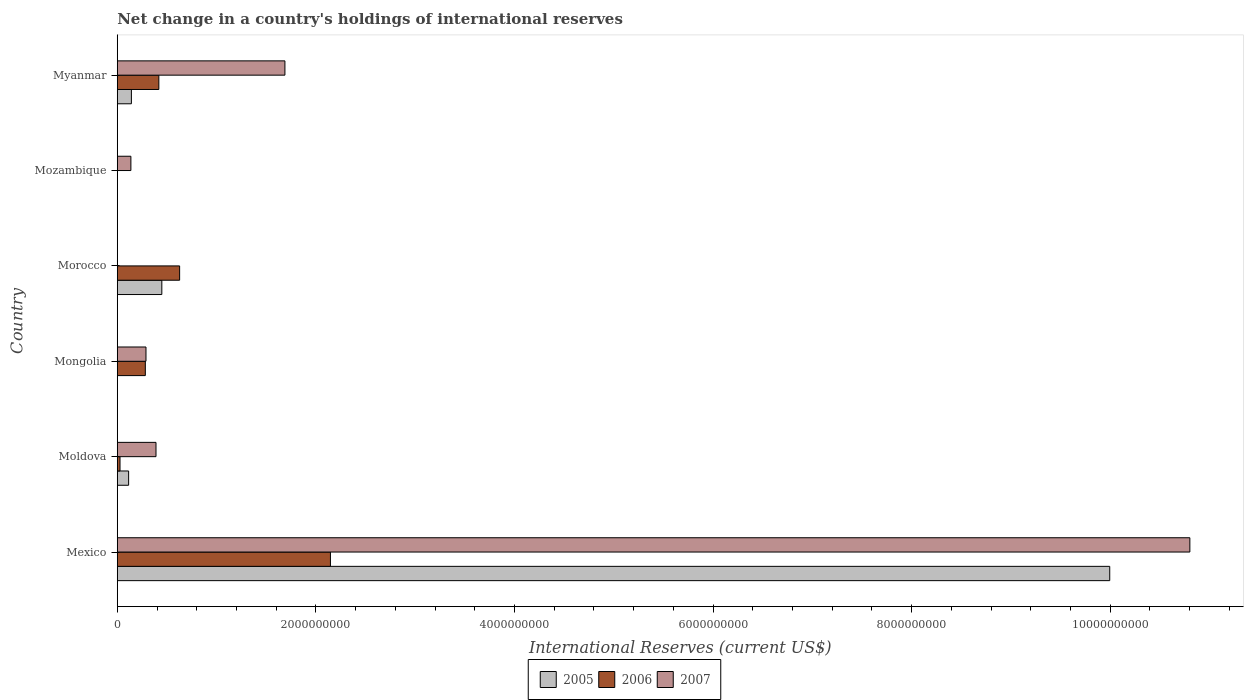How many different coloured bars are there?
Your answer should be compact. 3. How many bars are there on the 2nd tick from the bottom?
Provide a succinct answer. 3. What is the label of the 5th group of bars from the top?
Provide a short and direct response. Moldova. In how many cases, is the number of bars for a given country not equal to the number of legend labels?
Your answer should be very brief. 3. What is the international reserves in 2007 in Myanmar?
Offer a terse response. 1.69e+09. Across all countries, what is the maximum international reserves in 2006?
Ensure brevity in your answer.  2.15e+09. Across all countries, what is the minimum international reserves in 2007?
Make the answer very short. 0. In which country was the international reserves in 2007 maximum?
Offer a very short reply. Mexico. What is the total international reserves in 2005 in the graph?
Offer a very short reply. 1.07e+1. What is the difference between the international reserves in 2005 in Moldova and that in Morocco?
Make the answer very short. -3.35e+08. What is the difference between the international reserves in 2006 in Myanmar and the international reserves in 2007 in Mexico?
Keep it short and to the point. -1.04e+1. What is the average international reserves in 2006 per country?
Give a very brief answer. 5.84e+08. What is the difference between the international reserves in 2007 and international reserves in 2005 in Moldova?
Ensure brevity in your answer.  2.76e+08. In how many countries, is the international reserves in 2005 greater than 1600000000 US$?
Make the answer very short. 1. What is the ratio of the international reserves in 2007 in Mexico to that in Mozambique?
Offer a terse response. 78.79. What is the difference between the highest and the second highest international reserves in 2007?
Your response must be concise. 9.11e+09. What is the difference between the highest and the lowest international reserves in 2005?
Ensure brevity in your answer.  1.00e+1. In how many countries, is the international reserves in 2007 greater than the average international reserves in 2007 taken over all countries?
Make the answer very short. 1. Is the sum of the international reserves in 2007 in Moldova and Mozambique greater than the maximum international reserves in 2006 across all countries?
Offer a terse response. No. Are all the bars in the graph horizontal?
Offer a very short reply. Yes. How many countries are there in the graph?
Offer a very short reply. 6. Does the graph contain grids?
Keep it short and to the point. No. How many legend labels are there?
Keep it short and to the point. 3. How are the legend labels stacked?
Make the answer very short. Horizontal. What is the title of the graph?
Your response must be concise. Net change in a country's holdings of international reserves. What is the label or title of the X-axis?
Keep it short and to the point. International Reserves (current US$). What is the International Reserves (current US$) in 2005 in Mexico?
Offer a terse response. 1.00e+1. What is the International Reserves (current US$) of 2006 in Mexico?
Offer a terse response. 2.15e+09. What is the International Reserves (current US$) in 2007 in Mexico?
Keep it short and to the point. 1.08e+1. What is the International Reserves (current US$) of 2005 in Moldova?
Keep it short and to the point. 1.14e+08. What is the International Reserves (current US$) of 2006 in Moldova?
Give a very brief answer. 2.75e+07. What is the International Reserves (current US$) in 2007 in Moldova?
Make the answer very short. 3.90e+08. What is the International Reserves (current US$) of 2006 in Mongolia?
Keep it short and to the point. 2.83e+08. What is the International Reserves (current US$) of 2007 in Mongolia?
Offer a terse response. 2.89e+08. What is the International Reserves (current US$) of 2005 in Morocco?
Give a very brief answer. 4.49e+08. What is the International Reserves (current US$) of 2006 in Morocco?
Your answer should be very brief. 6.28e+08. What is the International Reserves (current US$) of 2007 in Morocco?
Provide a short and direct response. 0. What is the International Reserves (current US$) in 2006 in Mozambique?
Offer a very short reply. 0. What is the International Reserves (current US$) of 2007 in Mozambique?
Your response must be concise. 1.37e+08. What is the International Reserves (current US$) in 2005 in Myanmar?
Your response must be concise. 1.42e+08. What is the International Reserves (current US$) in 2006 in Myanmar?
Keep it short and to the point. 4.19e+08. What is the International Reserves (current US$) in 2007 in Myanmar?
Offer a terse response. 1.69e+09. Across all countries, what is the maximum International Reserves (current US$) of 2005?
Keep it short and to the point. 1.00e+1. Across all countries, what is the maximum International Reserves (current US$) in 2006?
Give a very brief answer. 2.15e+09. Across all countries, what is the maximum International Reserves (current US$) in 2007?
Offer a very short reply. 1.08e+1. Across all countries, what is the minimum International Reserves (current US$) of 2005?
Provide a short and direct response. 0. What is the total International Reserves (current US$) of 2005 in the graph?
Provide a succinct answer. 1.07e+1. What is the total International Reserves (current US$) of 2006 in the graph?
Keep it short and to the point. 3.50e+09. What is the total International Reserves (current US$) of 2007 in the graph?
Your answer should be very brief. 1.33e+1. What is the difference between the International Reserves (current US$) of 2005 in Mexico and that in Moldova?
Your answer should be very brief. 9.88e+09. What is the difference between the International Reserves (current US$) in 2006 in Mexico and that in Moldova?
Your response must be concise. 2.12e+09. What is the difference between the International Reserves (current US$) of 2007 in Mexico and that in Moldova?
Ensure brevity in your answer.  1.04e+1. What is the difference between the International Reserves (current US$) in 2006 in Mexico and that in Mongolia?
Give a very brief answer. 1.86e+09. What is the difference between the International Reserves (current US$) in 2007 in Mexico and that in Mongolia?
Provide a succinct answer. 1.05e+1. What is the difference between the International Reserves (current US$) in 2005 in Mexico and that in Morocco?
Keep it short and to the point. 9.55e+09. What is the difference between the International Reserves (current US$) of 2006 in Mexico and that in Morocco?
Offer a terse response. 1.52e+09. What is the difference between the International Reserves (current US$) in 2007 in Mexico and that in Mozambique?
Ensure brevity in your answer.  1.07e+1. What is the difference between the International Reserves (current US$) of 2005 in Mexico and that in Myanmar?
Offer a very short reply. 9.85e+09. What is the difference between the International Reserves (current US$) of 2006 in Mexico and that in Myanmar?
Provide a short and direct response. 1.73e+09. What is the difference between the International Reserves (current US$) in 2007 in Mexico and that in Myanmar?
Your answer should be compact. 9.11e+09. What is the difference between the International Reserves (current US$) of 2006 in Moldova and that in Mongolia?
Offer a very short reply. -2.55e+08. What is the difference between the International Reserves (current US$) in 2007 in Moldova and that in Mongolia?
Provide a succinct answer. 1.01e+08. What is the difference between the International Reserves (current US$) in 2005 in Moldova and that in Morocco?
Your answer should be very brief. -3.35e+08. What is the difference between the International Reserves (current US$) in 2006 in Moldova and that in Morocco?
Ensure brevity in your answer.  -6.00e+08. What is the difference between the International Reserves (current US$) of 2007 in Moldova and that in Mozambique?
Make the answer very short. 2.53e+08. What is the difference between the International Reserves (current US$) in 2005 in Moldova and that in Myanmar?
Offer a terse response. -2.79e+07. What is the difference between the International Reserves (current US$) of 2006 in Moldova and that in Myanmar?
Your response must be concise. -3.91e+08. What is the difference between the International Reserves (current US$) of 2007 in Moldova and that in Myanmar?
Give a very brief answer. -1.30e+09. What is the difference between the International Reserves (current US$) in 2006 in Mongolia and that in Morocco?
Keep it short and to the point. -3.45e+08. What is the difference between the International Reserves (current US$) in 2007 in Mongolia and that in Mozambique?
Offer a terse response. 1.52e+08. What is the difference between the International Reserves (current US$) in 2006 in Mongolia and that in Myanmar?
Keep it short and to the point. -1.36e+08. What is the difference between the International Reserves (current US$) of 2007 in Mongolia and that in Myanmar?
Your answer should be compact. -1.40e+09. What is the difference between the International Reserves (current US$) in 2005 in Morocco and that in Myanmar?
Keep it short and to the point. 3.07e+08. What is the difference between the International Reserves (current US$) of 2006 in Morocco and that in Myanmar?
Make the answer very short. 2.09e+08. What is the difference between the International Reserves (current US$) of 2007 in Mozambique and that in Myanmar?
Offer a very short reply. -1.55e+09. What is the difference between the International Reserves (current US$) of 2005 in Mexico and the International Reserves (current US$) of 2006 in Moldova?
Your answer should be compact. 9.97e+09. What is the difference between the International Reserves (current US$) of 2005 in Mexico and the International Reserves (current US$) of 2007 in Moldova?
Provide a succinct answer. 9.61e+09. What is the difference between the International Reserves (current US$) in 2006 in Mexico and the International Reserves (current US$) in 2007 in Moldova?
Ensure brevity in your answer.  1.76e+09. What is the difference between the International Reserves (current US$) in 2005 in Mexico and the International Reserves (current US$) in 2006 in Mongolia?
Your response must be concise. 9.71e+09. What is the difference between the International Reserves (current US$) of 2005 in Mexico and the International Reserves (current US$) of 2007 in Mongolia?
Provide a short and direct response. 9.71e+09. What is the difference between the International Reserves (current US$) in 2006 in Mexico and the International Reserves (current US$) in 2007 in Mongolia?
Ensure brevity in your answer.  1.86e+09. What is the difference between the International Reserves (current US$) of 2005 in Mexico and the International Reserves (current US$) of 2006 in Morocco?
Provide a succinct answer. 9.37e+09. What is the difference between the International Reserves (current US$) in 2005 in Mexico and the International Reserves (current US$) in 2007 in Mozambique?
Your answer should be compact. 9.86e+09. What is the difference between the International Reserves (current US$) in 2006 in Mexico and the International Reserves (current US$) in 2007 in Mozambique?
Give a very brief answer. 2.01e+09. What is the difference between the International Reserves (current US$) in 2005 in Mexico and the International Reserves (current US$) in 2006 in Myanmar?
Ensure brevity in your answer.  9.58e+09. What is the difference between the International Reserves (current US$) of 2005 in Mexico and the International Reserves (current US$) of 2007 in Myanmar?
Offer a terse response. 8.31e+09. What is the difference between the International Reserves (current US$) in 2006 in Mexico and the International Reserves (current US$) in 2007 in Myanmar?
Your response must be concise. 4.58e+08. What is the difference between the International Reserves (current US$) of 2005 in Moldova and the International Reserves (current US$) of 2006 in Mongolia?
Provide a succinct answer. -1.68e+08. What is the difference between the International Reserves (current US$) of 2005 in Moldova and the International Reserves (current US$) of 2007 in Mongolia?
Keep it short and to the point. -1.75e+08. What is the difference between the International Reserves (current US$) in 2006 in Moldova and the International Reserves (current US$) in 2007 in Mongolia?
Give a very brief answer. -2.62e+08. What is the difference between the International Reserves (current US$) of 2005 in Moldova and the International Reserves (current US$) of 2006 in Morocco?
Give a very brief answer. -5.14e+08. What is the difference between the International Reserves (current US$) of 2005 in Moldova and the International Reserves (current US$) of 2007 in Mozambique?
Your answer should be very brief. -2.29e+07. What is the difference between the International Reserves (current US$) in 2006 in Moldova and the International Reserves (current US$) in 2007 in Mozambique?
Provide a short and direct response. -1.10e+08. What is the difference between the International Reserves (current US$) in 2005 in Moldova and the International Reserves (current US$) in 2006 in Myanmar?
Your answer should be compact. -3.04e+08. What is the difference between the International Reserves (current US$) in 2005 in Moldova and the International Reserves (current US$) in 2007 in Myanmar?
Your answer should be very brief. -1.57e+09. What is the difference between the International Reserves (current US$) of 2006 in Moldova and the International Reserves (current US$) of 2007 in Myanmar?
Ensure brevity in your answer.  -1.66e+09. What is the difference between the International Reserves (current US$) of 2006 in Mongolia and the International Reserves (current US$) of 2007 in Mozambique?
Your answer should be very brief. 1.45e+08. What is the difference between the International Reserves (current US$) in 2006 in Mongolia and the International Reserves (current US$) in 2007 in Myanmar?
Make the answer very short. -1.41e+09. What is the difference between the International Reserves (current US$) of 2005 in Morocco and the International Reserves (current US$) of 2007 in Mozambique?
Ensure brevity in your answer.  3.12e+08. What is the difference between the International Reserves (current US$) in 2006 in Morocco and the International Reserves (current US$) in 2007 in Mozambique?
Offer a very short reply. 4.91e+08. What is the difference between the International Reserves (current US$) of 2005 in Morocco and the International Reserves (current US$) of 2006 in Myanmar?
Provide a succinct answer. 3.01e+07. What is the difference between the International Reserves (current US$) of 2005 in Morocco and the International Reserves (current US$) of 2007 in Myanmar?
Your answer should be very brief. -1.24e+09. What is the difference between the International Reserves (current US$) in 2006 in Morocco and the International Reserves (current US$) in 2007 in Myanmar?
Ensure brevity in your answer.  -1.06e+09. What is the average International Reserves (current US$) in 2005 per country?
Offer a very short reply. 1.78e+09. What is the average International Reserves (current US$) of 2006 per country?
Keep it short and to the point. 5.84e+08. What is the average International Reserves (current US$) in 2007 per country?
Your answer should be compact. 2.22e+09. What is the difference between the International Reserves (current US$) of 2005 and International Reserves (current US$) of 2006 in Mexico?
Give a very brief answer. 7.85e+09. What is the difference between the International Reserves (current US$) of 2005 and International Reserves (current US$) of 2007 in Mexico?
Offer a very short reply. -8.07e+08. What is the difference between the International Reserves (current US$) of 2006 and International Reserves (current US$) of 2007 in Mexico?
Offer a terse response. -8.66e+09. What is the difference between the International Reserves (current US$) of 2005 and International Reserves (current US$) of 2006 in Moldova?
Offer a terse response. 8.67e+07. What is the difference between the International Reserves (current US$) in 2005 and International Reserves (current US$) in 2007 in Moldova?
Make the answer very short. -2.76e+08. What is the difference between the International Reserves (current US$) of 2006 and International Reserves (current US$) of 2007 in Moldova?
Your response must be concise. -3.62e+08. What is the difference between the International Reserves (current US$) of 2006 and International Reserves (current US$) of 2007 in Mongolia?
Make the answer very short. -6.62e+06. What is the difference between the International Reserves (current US$) of 2005 and International Reserves (current US$) of 2006 in Morocco?
Give a very brief answer. -1.79e+08. What is the difference between the International Reserves (current US$) of 2005 and International Reserves (current US$) of 2006 in Myanmar?
Your response must be concise. -2.77e+08. What is the difference between the International Reserves (current US$) in 2005 and International Reserves (current US$) in 2007 in Myanmar?
Give a very brief answer. -1.55e+09. What is the difference between the International Reserves (current US$) of 2006 and International Reserves (current US$) of 2007 in Myanmar?
Keep it short and to the point. -1.27e+09. What is the ratio of the International Reserves (current US$) of 2005 in Mexico to that in Moldova?
Your answer should be compact. 87.52. What is the ratio of the International Reserves (current US$) of 2006 in Mexico to that in Moldova?
Ensure brevity in your answer.  78.11. What is the ratio of the International Reserves (current US$) of 2007 in Mexico to that in Moldova?
Provide a short and direct response. 27.7. What is the ratio of the International Reserves (current US$) of 2006 in Mexico to that in Mongolia?
Your answer should be very brief. 7.6. What is the ratio of the International Reserves (current US$) in 2007 in Mexico to that in Mongolia?
Your answer should be very brief. 37.36. What is the ratio of the International Reserves (current US$) in 2005 in Mexico to that in Morocco?
Offer a terse response. 22.28. What is the ratio of the International Reserves (current US$) of 2006 in Mexico to that in Morocco?
Your response must be concise. 3.42. What is the ratio of the International Reserves (current US$) of 2007 in Mexico to that in Mozambique?
Ensure brevity in your answer.  78.79. What is the ratio of the International Reserves (current US$) of 2005 in Mexico to that in Myanmar?
Offer a very short reply. 70.34. What is the ratio of the International Reserves (current US$) in 2006 in Mexico to that in Myanmar?
Provide a succinct answer. 5.13. What is the ratio of the International Reserves (current US$) of 2007 in Mexico to that in Myanmar?
Offer a very short reply. 6.4. What is the ratio of the International Reserves (current US$) in 2006 in Moldova to that in Mongolia?
Offer a terse response. 0.1. What is the ratio of the International Reserves (current US$) in 2007 in Moldova to that in Mongolia?
Give a very brief answer. 1.35. What is the ratio of the International Reserves (current US$) in 2005 in Moldova to that in Morocco?
Your answer should be compact. 0.25. What is the ratio of the International Reserves (current US$) of 2006 in Moldova to that in Morocco?
Provide a succinct answer. 0.04. What is the ratio of the International Reserves (current US$) in 2007 in Moldova to that in Mozambique?
Your answer should be very brief. 2.84. What is the ratio of the International Reserves (current US$) in 2005 in Moldova to that in Myanmar?
Ensure brevity in your answer.  0.8. What is the ratio of the International Reserves (current US$) of 2006 in Moldova to that in Myanmar?
Provide a succinct answer. 0.07. What is the ratio of the International Reserves (current US$) of 2007 in Moldova to that in Myanmar?
Give a very brief answer. 0.23. What is the ratio of the International Reserves (current US$) of 2006 in Mongolia to that in Morocco?
Provide a short and direct response. 0.45. What is the ratio of the International Reserves (current US$) in 2007 in Mongolia to that in Mozambique?
Give a very brief answer. 2.11. What is the ratio of the International Reserves (current US$) in 2006 in Mongolia to that in Myanmar?
Keep it short and to the point. 0.67. What is the ratio of the International Reserves (current US$) of 2007 in Mongolia to that in Myanmar?
Ensure brevity in your answer.  0.17. What is the ratio of the International Reserves (current US$) of 2005 in Morocco to that in Myanmar?
Keep it short and to the point. 3.16. What is the ratio of the International Reserves (current US$) of 2006 in Morocco to that in Myanmar?
Give a very brief answer. 1.5. What is the ratio of the International Reserves (current US$) in 2007 in Mozambique to that in Myanmar?
Your answer should be compact. 0.08. What is the difference between the highest and the second highest International Reserves (current US$) in 2005?
Make the answer very short. 9.55e+09. What is the difference between the highest and the second highest International Reserves (current US$) in 2006?
Your response must be concise. 1.52e+09. What is the difference between the highest and the second highest International Reserves (current US$) in 2007?
Your answer should be very brief. 9.11e+09. What is the difference between the highest and the lowest International Reserves (current US$) of 2005?
Offer a terse response. 1.00e+1. What is the difference between the highest and the lowest International Reserves (current US$) in 2006?
Offer a very short reply. 2.15e+09. What is the difference between the highest and the lowest International Reserves (current US$) of 2007?
Offer a terse response. 1.08e+1. 